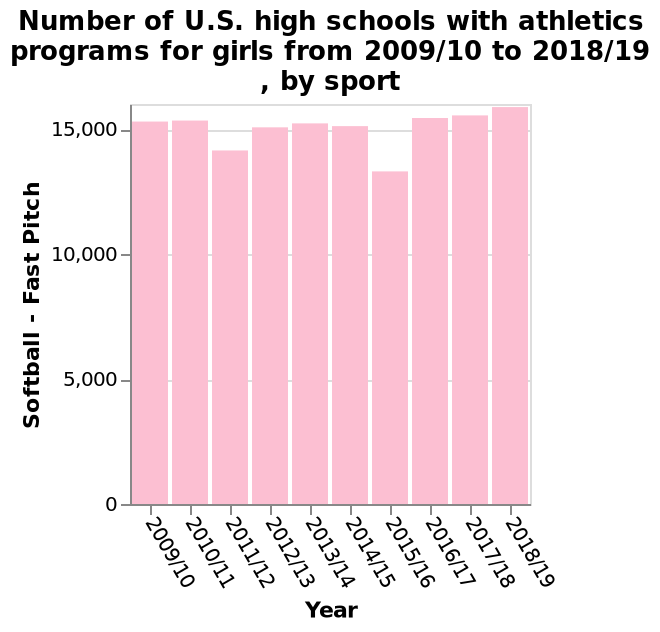<image>
please describe the details of the chart Number of U.S. high schools with athletics programs for girls from 2009/10 to 2018/19 , by sport is a bar graph. The x-axis measures Year. Along the y-axis, Softball - Fast Pitch is shown with a linear scale with a minimum of 0 and a maximum of 15,000. please summary the statistics and relations of the chart The number of U.S. high schools with athletics programs for girls playing softball - Fast Pitch from 2009/10 to 2018/19 has stayed mostly stable. Did the number of U.S. high schools with athletics programs for girls playing softball - Fast Pitch remain constant throughout the years from 2009/10 to 2018/19? While there might have been minor changes, the number of U.S. high schools with athletics programs for girls playing softball - Fast Pitch can be considered relatively constant during this period. How many U.S. high schools had athletics programs for girls participating in Softball - Fast Pitch in the year 2018/19? 15,000 U.S. high schools had athletics programs for girls participating in Softball - Fast Pitch in the year 2018/19. Is the sentence "Number of U.S. high schools with athletics programs for girls from 2009/10 to 2018/19, by sport is a pie chart" an interrogative sentence? 
No. No.Number of U.S. high schools with athletics programs for girls from 2009/10 to 2018/19 , by sport is a bar graph. The x-axis measures Year. Along the y-axis, Softball - Fast Pitch is shown with a linear scale with a minimum of 0 and a maximum of 15,000. 